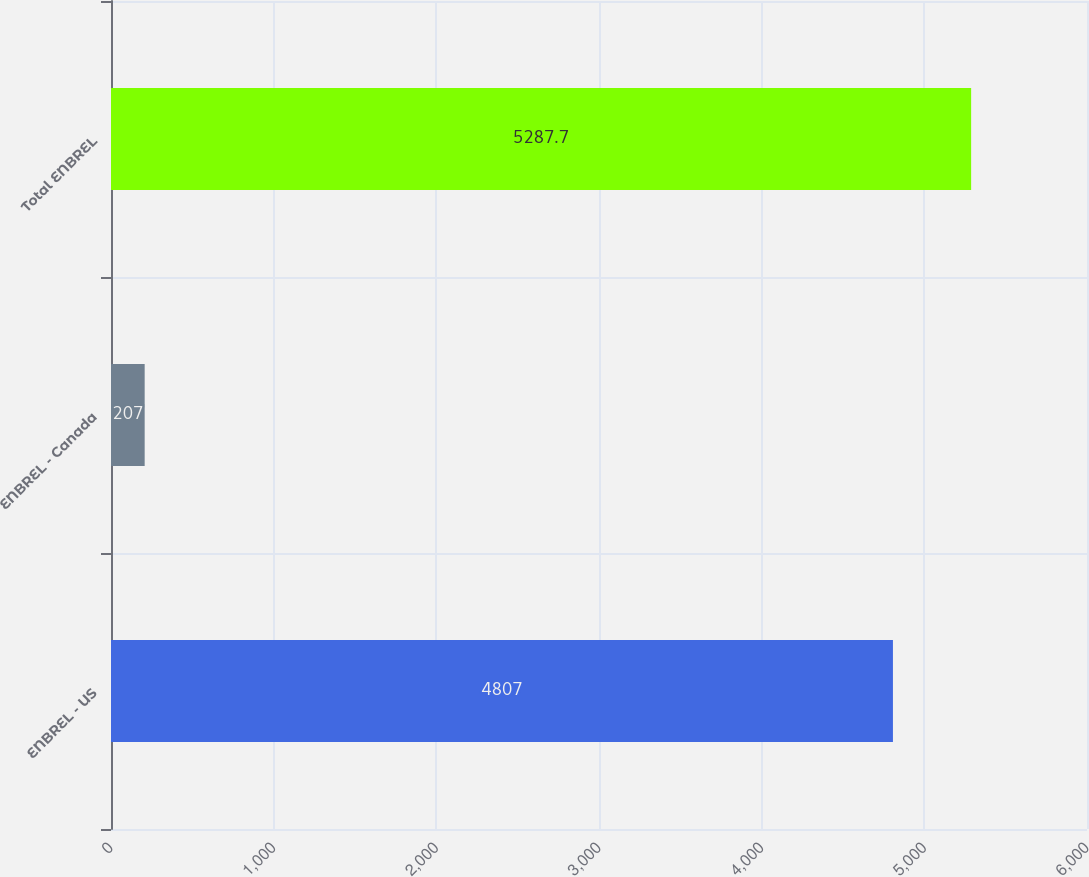Convert chart. <chart><loc_0><loc_0><loc_500><loc_500><bar_chart><fcel>ENBREL - US<fcel>ENBREL - Canada<fcel>Total ENBREL<nl><fcel>4807<fcel>207<fcel>5287.7<nl></chart> 